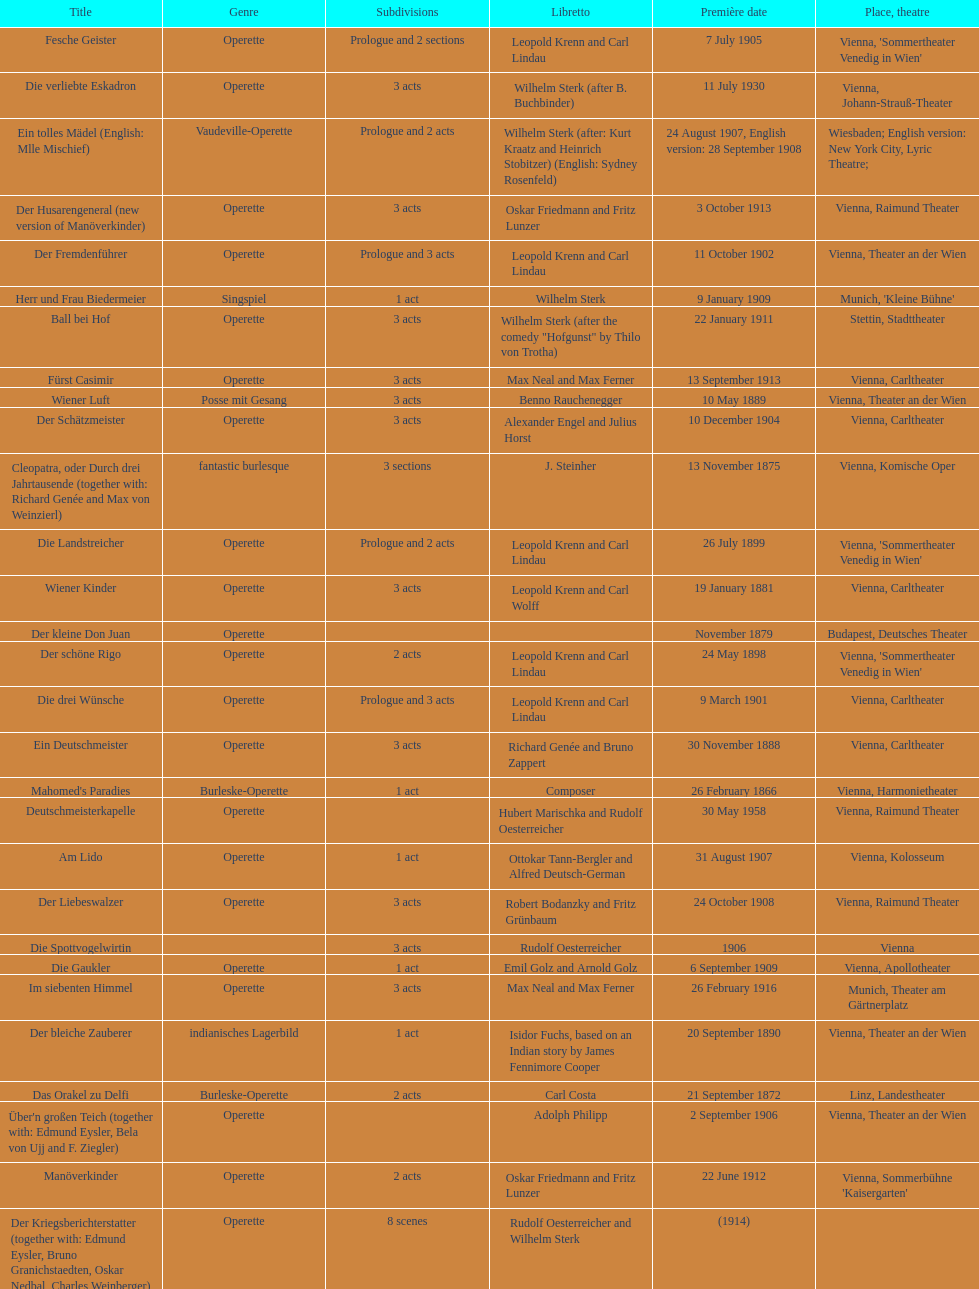All the dates are no later than what year? 1958. 